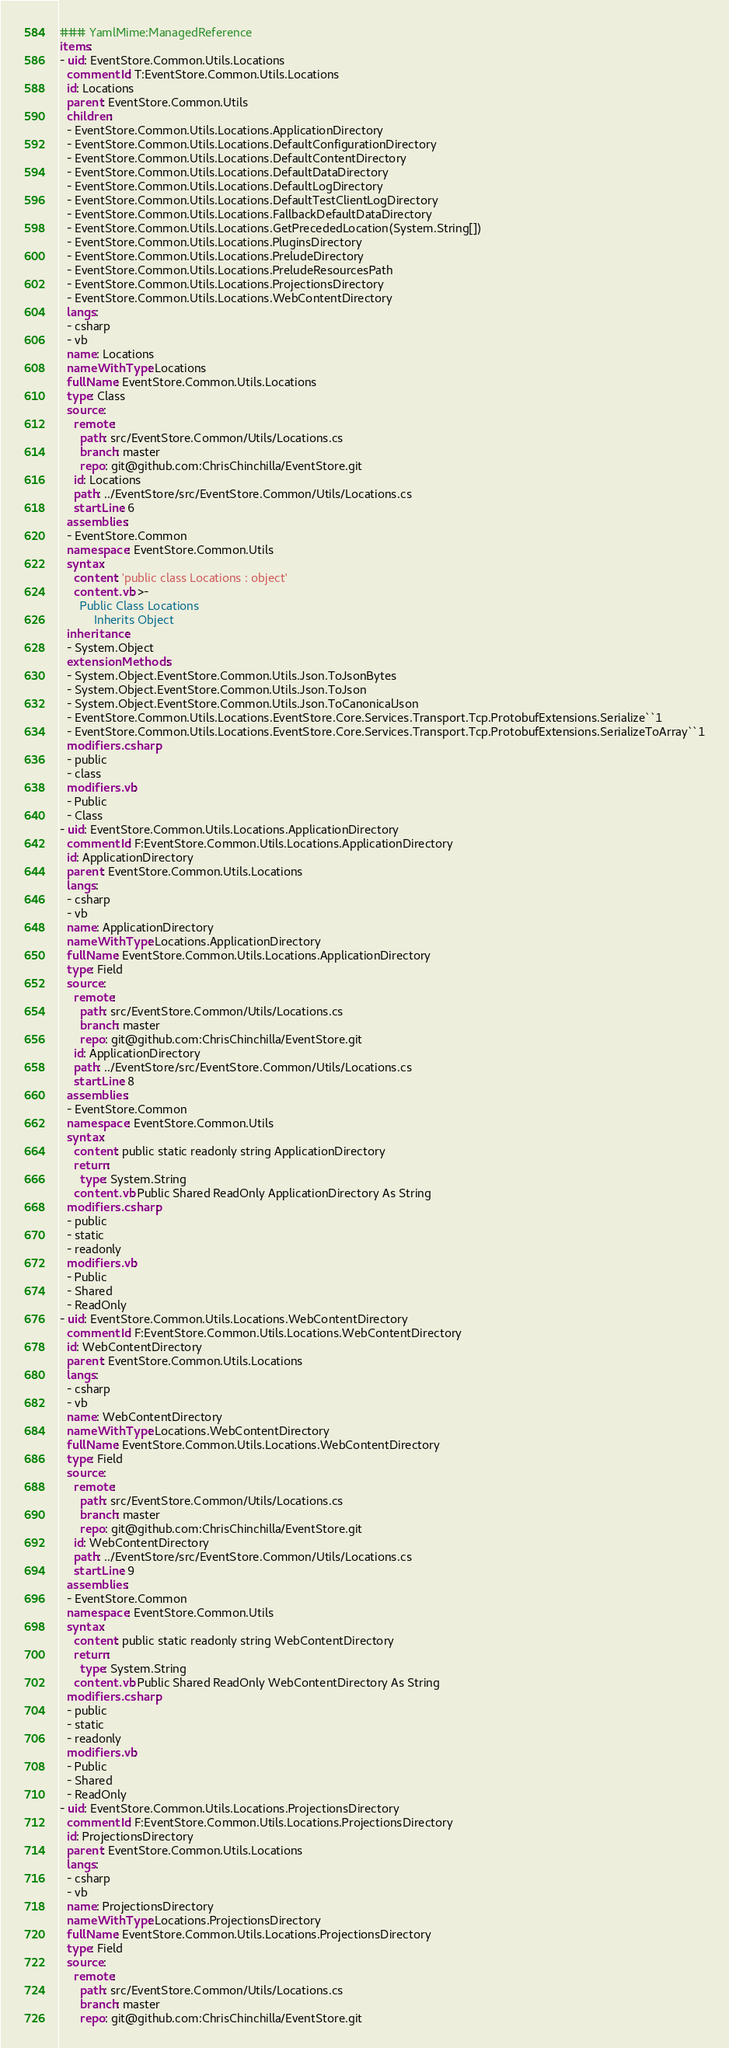Convert code to text. <code><loc_0><loc_0><loc_500><loc_500><_YAML_>### YamlMime:ManagedReference
items:
- uid: EventStore.Common.Utils.Locations
  commentId: T:EventStore.Common.Utils.Locations
  id: Locations
  parent: EventStore.Common.Utils
  children:
  - EventStore.Common.Utils.Locations.ApplicationDirectory
  - EventStore.Common.Utils.Locations.DefaultConfigurationDirectory
  - EventStore.Common.Utils.Locations.DefaultContentDirectory
  - EventStore.Common.Utils.Locations.DefaultDataDirectory
  - EventStore.Common.Utils.Locations.DefaultLogDirectory
  - EventStore.Common.Utils.Locations.DefaultTestClientLogDirectory
  - EventStore.Common.Utils.Locations.FallbackDefaultDataDirectory
  - EventStore.Common.Utils.Locations.GetPrecededLocation(System.String[])
  - EventStore.Common.Utils.Locations.PluginsDirectory
  - EventStore.Common.Utils.Locations.PreludeDirectory
  - EventStore.Common.Utils.Locations.PreludeResourcesPath
  - EventStore.Common.Utils.Locations.ProjectionsDirectory
  - EventStore.Common.Utils.Locations.WebContentDirectory
  langs:
  - csharp
  - vb
  name: Locations
  nameWithType: Locations
  fullName: EventStore.Common.Utils.Locations
  type: Class
  source:
    remote:
      path: src/EventStore.Common/Utils/Locations.cs
      branch: master
      repo: git@github.com:ChrisChinchilla/EventStore.git
    id: Locations
    path: ../EventStore/src/EventStore.Common/Utils/Locations.cs
    startLine: 6
  assemblies:
  - EventStore.Common
  namespace: EventStore.Common.Utils
  syntax:
    content: 'public class Locations : object'
    content.vb: >-
      Public Class Locations
          Inherits Object
  inheritance:
  - System.Object
  extensionMethods:
  - System.Object.EventStore.Common.Utils.Json.ToJsonBytes
  - System.Object.EventStore.Common.Utils.Json.ToJson
  - System.Object.EventStore.Common.Utils.Json.ToCanonicalJson
  - EventStore.Common.Utils.Locations.EventStore.Core.Services.Transport.Tcp.ProtobufExtensions.Serialize``1
  - EventStore.Common.Utils.Locations.EventStore.Core.Services.Transport.Tcp.ProtobufExtensions.SerializeToArray``1
  modifiers.csharp:
  - public
  - class
  modifiers.vb:
  - Public
  - Class
- uid: EventStore.Common.Utils.Locations.ApplicationDirectory
  commentId: F:EventStore.Common.Utils.Locations.ApplicationDirectory
  id: ApplicationDirectory
  parent: EventStore.Common.Utils.Locations
  langs:
  - csharp
  - vb
  name: ApplicationDirectory
  nameWithType: Locations.ApplicationDirectory
  fullName: EventStore.Common.Utils.Locations.ApplicationDirectory
  type: Field
  source:
    remote:
      path: src/EventStore.Common/Utils/Locations.cs
      branch: master
      repo: git@github.com:ChrisChinchilla/EventStore.git
    id: ApplicationDirectory
    path: ../EventStore/src/EventStore.Common/Utils/Locations.cs
    startLine: 8
  assemblies:
  - EventStore.Common
  namespace: EventStore.Common.Utils
  syntax:
    content: public static readonly string ApplicationDirectory
    return:
      type: System.String
    content.vb: Public Shared ReadOnly ApplicationDirectory As String
  modifiers.csharp:
  - public
  - static
  - readonly
  modifiers.vb:
  - Public
  - Shared
  - ReadOnly
- uid: EventStore.Common.Utils.Locations.WebContentDirectory
  commentId: F:EventStore.Common.Utils.Locations.WebContentDirectory
  id: WebContentDirectory
  parent: EventStore.Common.Utils.Locations
  langs:
  - csharp
  - vb
  name: WebContentDirectory
  nameWithType: Locations.WebContentDirectory
  fullName: EventStore.Common.Utils.Locations.WebContentDirectory
  type: Field
  source:
    remote:
      path: src/EventStore.Common/Utils/Locations.cs
      branch: master
      repo: git@github.com:ChrisChinchilla/EventStore.git
    id: WebContentDirectory
    path: ../EventStore/src/EventStore.Common/Utils/Locations.cs
    startLine: 9
  assemblies:
  - EventStore.Common
  namespace: EventStore.Common.Utils
  syntax:
    content: public static readonly string WebContentDirectory
    return:
      type: System.String
    content.vb: Public Shared ReadOnly WebContentDirectory As String
  modifiers.csharp:
  - public
  - static
  - readonly
  modifiers.vb:
  - Public
  - Shared
  - ReadOnly
- uid: EventStore.Common.Utils.Locations.ProjectionsDirectory
  commentId: F:EventStore.Common.Utils.Locations.ProjectionsDirectory
  id: ProjectionsDirectory
  parent: EventStore.Common.Utils.Locations
  langs:
  - csharp
  - vb
  name: ProjectionsDirectory
  nameWithType: Locations.ProjectionsDirectory
  fullName: EventStore.Common.Utils.Locations.ProjectionsDirectory
  type: Field
  source:
    remote:
      path: src/EventStore.Common/Utils/Locations.cs
      branch: master
      repo: git@github.com:ChrisChinchilla/EventStore.git</code> 